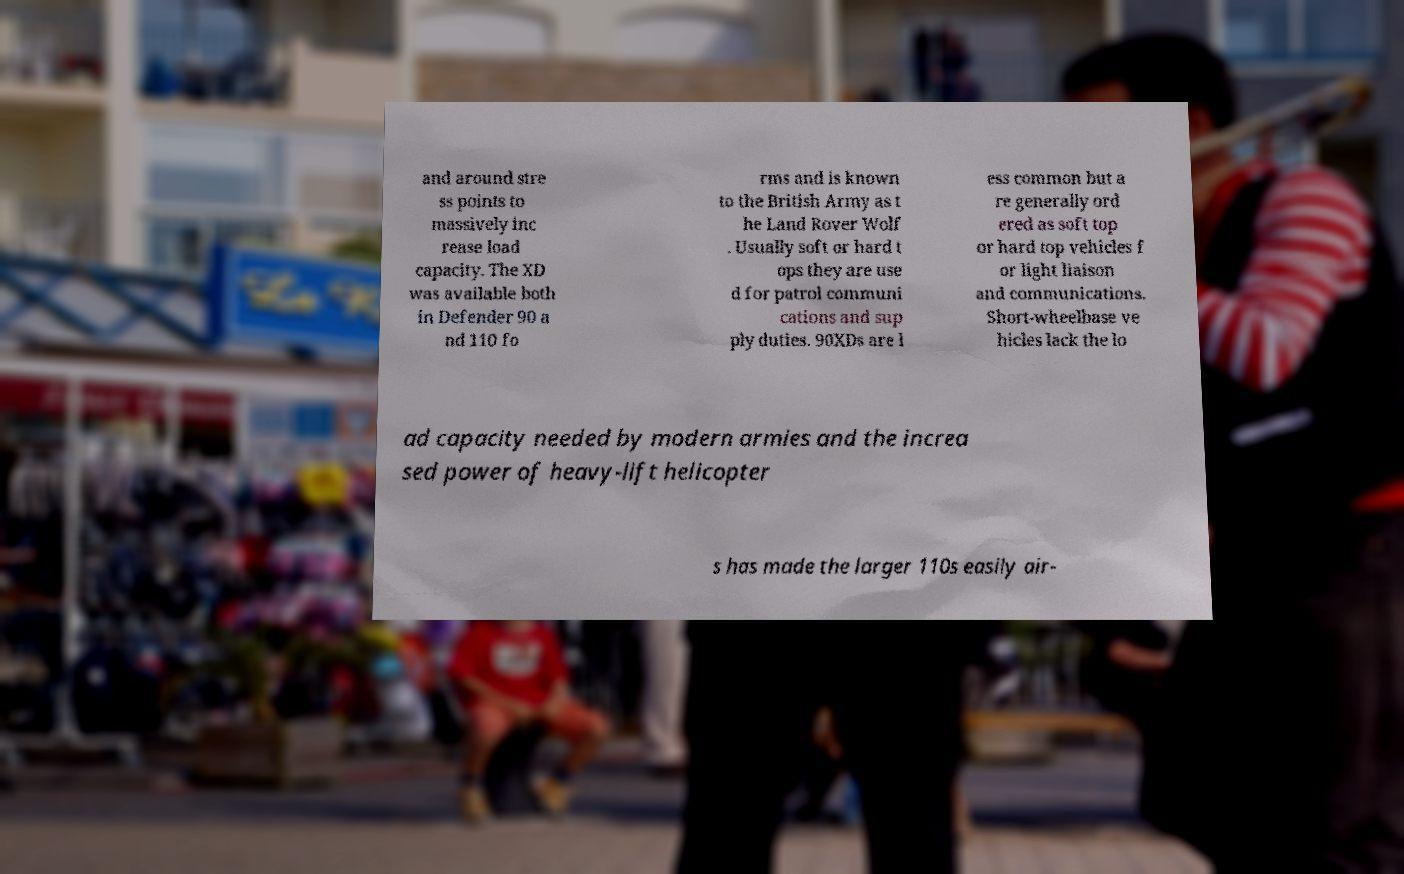There's text embedded in this image that I need extracted. Can you transcribe it verbatim? and around stre ss points to massively inc rease load capacity. The XD was available both in Defender 90 a nd 110 fo rms and is known to the British Army as t he Land Rover Wolf . Usually soft or hard t ops they are use d for patrol communi cations and sup ply duties. 90XDs are l ess common but a re generally ord ered as soft top or hard top vehicles f or light liaison and communications. Short-wheelbase ve hicles lack the lo ad capacity needed by modern armies and the increa sed power of heavy-lift helicopter s has made the larger 110s easily air- 